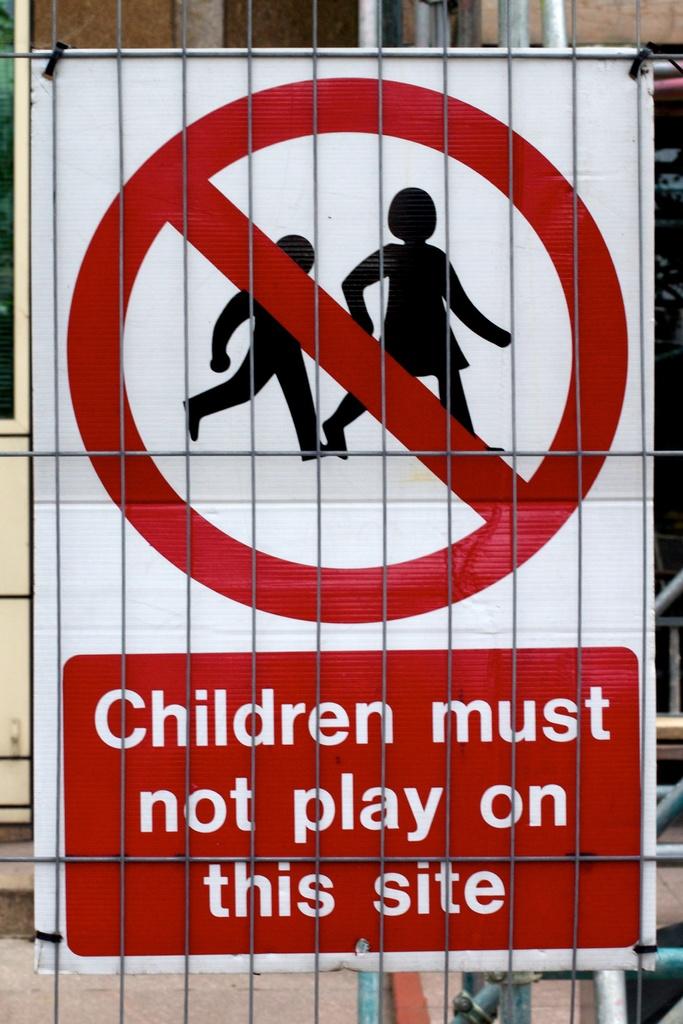What does the sign tell you not to do?
Your response must be concise. Children must not play on this site. 